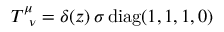Convert formula to latex. <formula><loc_0><loc_0><loc_500><loc_500>T _ { \, \nu } ^ { \mu } = \delta ( z ) \, \sigma \, { d i a g } ( 1 , 1 , 1 , 0 )</formula> 